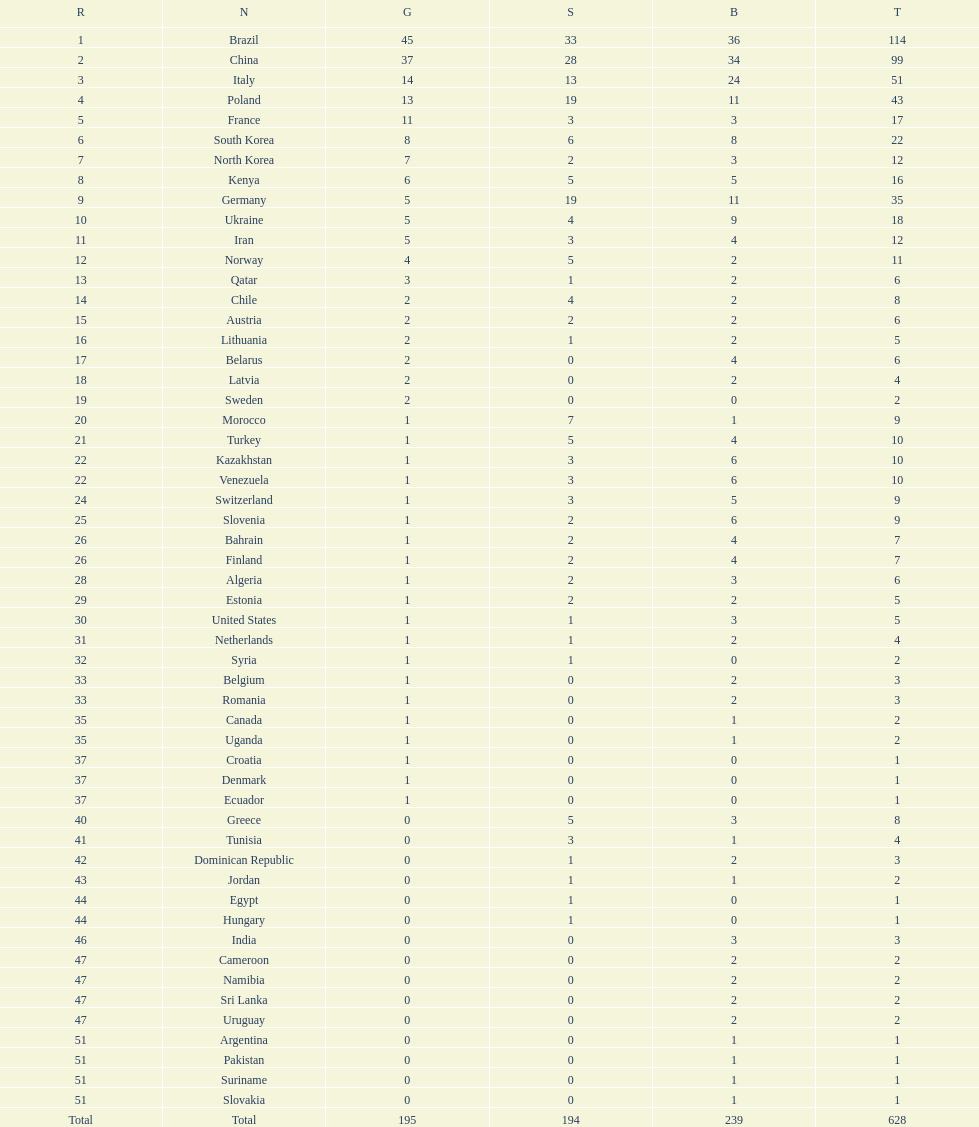What is the difference in the number of medals between south korea and north korea? 10. 